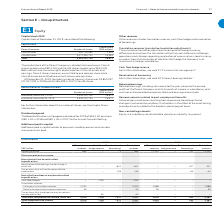According to Lm Ericsson Telephone's financial document, How are the capital stock of the parent company divided? Class A shares (quota value SEK 5.00) and Class B shares (quota value SEK 5.00). The document states: "of the Parent Company is divided into two classes: Class A shares (quota value SEK 5.00) and Class B shares (quota value SEK 5.00). Both classes have ..." Also, What is the total number of treasury shares in 2019? According to the financial document, 19,853,247. The relevant text states: "31, 2019, the total number of treasury shares was 19,853,247 (37,057,039 in 2018 and 50,265,499 in 2017) Class B shares...." Also, How many votes are class A shares entitled? According to the financial document, one vote per share. The relevant text states: "arnings. Class A shares, however, are entitled to one vote per share while Class B shares are entitled to one tenth of one vote per share. At December 31, 2019, the tot arnings. Class A shares, howeve..." Also, can you calculate: What is the difference in the number of shares between class A and class B? Based on the calculation: 3,072,395,752-261,755,983, the result is 2810639769. This is based on the information: "Class A shares 261,755,983 1,309 Class B shares 3,072,395,752 15,363 Class A shares 261,755,983 1,309 Class B shares 3,072,395,752 15,363..." The key data points involved are: 261,755,983, 3,072,395,752. Also, can you calculate: What is the difference between capital stock value in class A and B shares? Based on the calculation: 15,363-1,309, the result is 14054 (in millions). This is based on the information: "es 261,755,983 1,309 Class B shares 3,072,395,752 15,363 Class A shares 261,755,983 1,309 Class B shares 3,072,395,752 15,363..." The key data points involved are: 1,309, 15,363. Also, can you calculate: What is the price of each class A share?  To answer this question, I need to perform calculations using the financial data. The calculation is: 1,309*1million/261,755,983, which equals 5. This is based on the information: "Class A shares 261,755,983 1,309 Class B shares 3,072,395,752 15,363 Class A shares 261,755,983 1,309 Class B shares 3,072,395,752 15,363 Class A shares 261,755,983 1,309 Class B shares 3,072,395,752 ..." The key data points involved are: 1, 1,309, 261,755,983. 